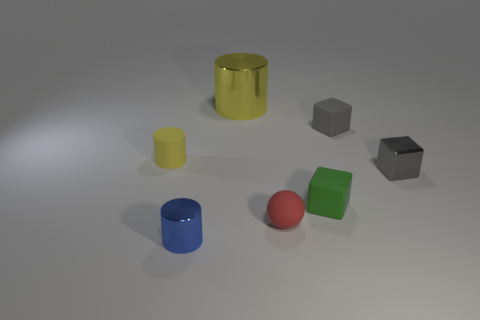Subtract all gray blocks. How many were subtracted if there are1gray blocks left? 1 Subtract all green matte blocks. How many blocks are left? 2 Add 3 gray metal cubes. How many objects exist? 10 Subtract all spheres. How many objects are left? 6 Add 3 large yellow metal things. How many large yellow metal things are left? 4 Add 3 small metallic blocks. How many small metallic blocks exist? 4 Subtract all green blocks. How many blocks are left? 2 Subtract 0 purple blocks. How many objects are left? 7 Subtract 3 cylinders. How many cylinders are left? 0 Subtract all yellow cylinders. Subtract all brown cubes. How many cylinders are left? 1 